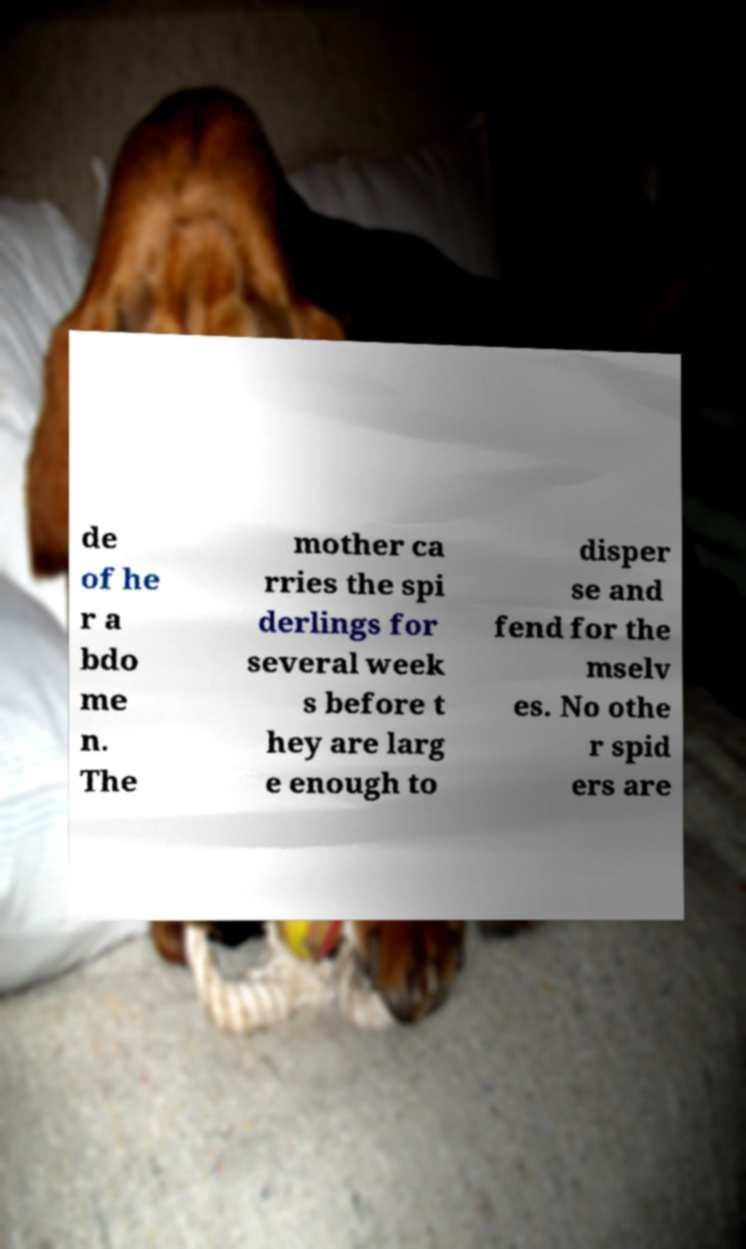I need the written content from this picture converted into text. Can you do that? de of he r a bdo me n. The mother ca rries the spi derlings for several week s before t hey are larg e enough to disper se and fend for the mselv es. No othe r spid ers are 